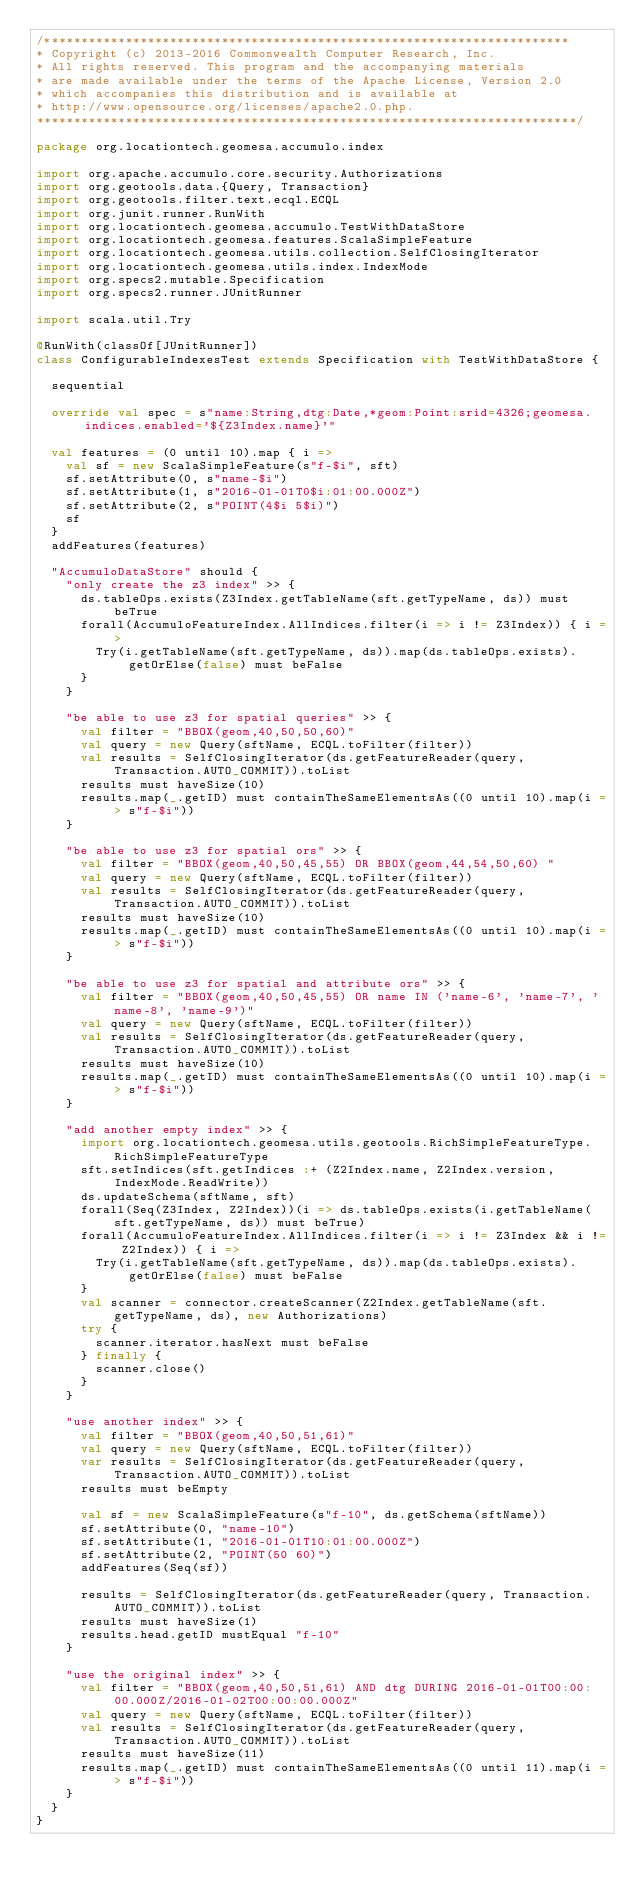<code> <loc_0><loc_0><loc_500><loc_500><_Scala_>/***********************************************************************
* Copyright (c) 2013-2016 Commonwealth Computer Research, Inc.
* All rights reserved. This program and the accompanying materials
* are made available under the terms of the Apache License, Version 2.0
* which accompanies this distribution and is available at
* http://www.opensource.org/licenses/apache2.0.php.
*************************************************************************/

package org.locationtech.geomesa.accumulo.index

import org.apache.accumulo.core.security.Authorizations
import org.geotools.data.{Query, Transaction}
import org.geotools.filter.text.ecql.ECQL
import org.junit.runner.RunWith
import org.locationtech.geomesa.accumulo.TestWithDataStore
import org.locationtech.geomesa.features.ScalaSimpleFeature
import org.locationtech.geomesa.utils.collection.SelfClosingIterator
import org.locationtech.geomesa.utils.index.IndexMode
import org.specs2.mutable.Specification
import org.specs2.runner.JUnitRunner

import scala.util.Try

@RunWith(classOf[JUnitRunner])
class ConfigurableIndexesTest extends Specification with TestWithDataStore {

  sequential

  override val spec = s"name:String,dtg:Date,*geom:Point:srid=4326;geomesa.indices.enabled='${Z3Index.name}'"

  val features = (0 until 10).map { i =>
    val sf = new ScalaSimpleFeature(s"f-$i", sft)
    sf.setAttribute(0, s"name-$i")
    sf.setAttribute(1, s"2016-01-01T0$i:01:00.000Z")
    sf.setAttribute(2, s"POINT(4$i 5$i)")
    sf
  }
  addFeatures(features)

  "AccumuloDataStore" should {
    "only create the z3 index" >> {
      ds.tableOps.exists(Z3Index.getTableName(sft.getTypeName, ds)) must beTrue
      forall(AccumuloFeatureIndex.AllIndices.filter(i => i != Z3Index)) { i =>
        Try(i.getTableName(sft.getTypeName, ds)).map(ds.tableOps.exists).getOrElse(false) must beFalse
      }
    }

    "be able to use z3 for spatial queries" >> {
      val filter = "BBOX(geom,40,50,50,60)"
      val query = new Query(sftName, ECQL.toFilter(filter))
      val results = SelfClosingIterator(ds.getFeatureReader(query, Transaction.AUTO_COMMIT)).toList
      results must haveSize(10)
      results.map(_.getID) must containTheSameElementsAs((0 until 10).map(i => s"f-$i"))
    }

    "be able to use z3 for spatial ors" >> {
      val filter = "BBOX(geom,40,50,45,55) OR BBOX(geom,44,54,50,60) "
      val query = new Query(sftName, ECQL.toFilter(filter))
      val results = SelfClosingIterator(ds.getFeatureReader(query, Transaction.AUTO_COMMIT)).toList
      results must haveSize(10)
      results.map(_.getID) must containTheSameElementsAs((0 until 10).map(i => s"f-$i"))
    }

    "be able to use z3 for spatial and attribute ors" >> {
      val filter = "BBOX(geom,40,50,45,55) OR name IN ('name-6', 'name-7', 'name-8', 'name-9')"
      val query = new Query(sftName, ECQL.toFilter(filter))
      val results = SelfClosingIterator(ds.getFeatureReader(query, Transaction.AUTO_COMMIT)).toList
      results must haveSize(10)
      results.map(_.getID) must containTheSameElementsAs((0 until 10).map(i => s"f-$i"))
    }

    "add another empty index" >> {
      import org.locationtech.geomesa.utils.geotools.RichSimpleFeatureType.RichSimpleFeatureType
      sft.setIndices(sft.getIndices :+ (Z2Index.name, Z2Index.version, IndexMode.ReadWrite))
      ds.updateSchema(sftName, sft)
      forall(Seq(Z3Index, Z2Index))(i => ds.tableOps.exists(i.getTableName(sft.getTypeName, ds)) must beTrue)
      forall(AccumuloFeatureIndex.AllIndices.filter(i => i != Z3Index && i != Z2Index)) { i =>
        Try(i.getTableName(sft.getTypeName, ds)).map(ds.tableOps.exists).getOrElse(false) must beFalse
      }
      val scanner = connector.createScanner(Z2Index.getTableName(sft.getTypeName, ds), new Authorizations)
      try {
        scanner.iterator.hasNext must beFalse
      } finally {
        scanner.close()
      }
    }

    "use another index" >> {
      val filter = "BBOX(geom,40,50,51,61)"
      val query = new Query(sftName, ECQL.toFilter(filter))
      var results = SelfClosingIterator(ds.getFeatureReader(query, Transaction.AUTO_COMMIT)).toList
      results must beEmpty

      val sf = new ScalaSimpleFeature(s"f-10", ds.getSchema(sftName))
      sf.setAttribute(0, "name-10")
      sf.setAttribute(1, "2016-01-01T10:01:00.000Z")
      sf.setAttribute(2, "POINT(50 60)")
      addFeatures(Seq(sf))

      results = SelfClosingIterator(ds.getFeatureReader(query, Transaction.AUTO_COMMIT)).toList
      results must haveSize(1)
      results.head.getID mustEqual "f-10"
    }

    "use the original index" >> {
      val filter = "BBOX(geom,40,50,51,61) AND dtg DURING 2016-01-01T00:00:00.000Z/2016-01-02T00:00:00.000Z"
      val query = new Query(sftName, ECQL.toFilter(filter))
      val results = SelfClosingIterator(ds.getFeatureReader(query, Transaction.AUTO_COMMIT)).toList
      results must haveSize(11)
      results.map(_.getID) must containTheSameElementsAs((0 until 11).map(i => s"f-$i"))
    }
  }
}
</code> 